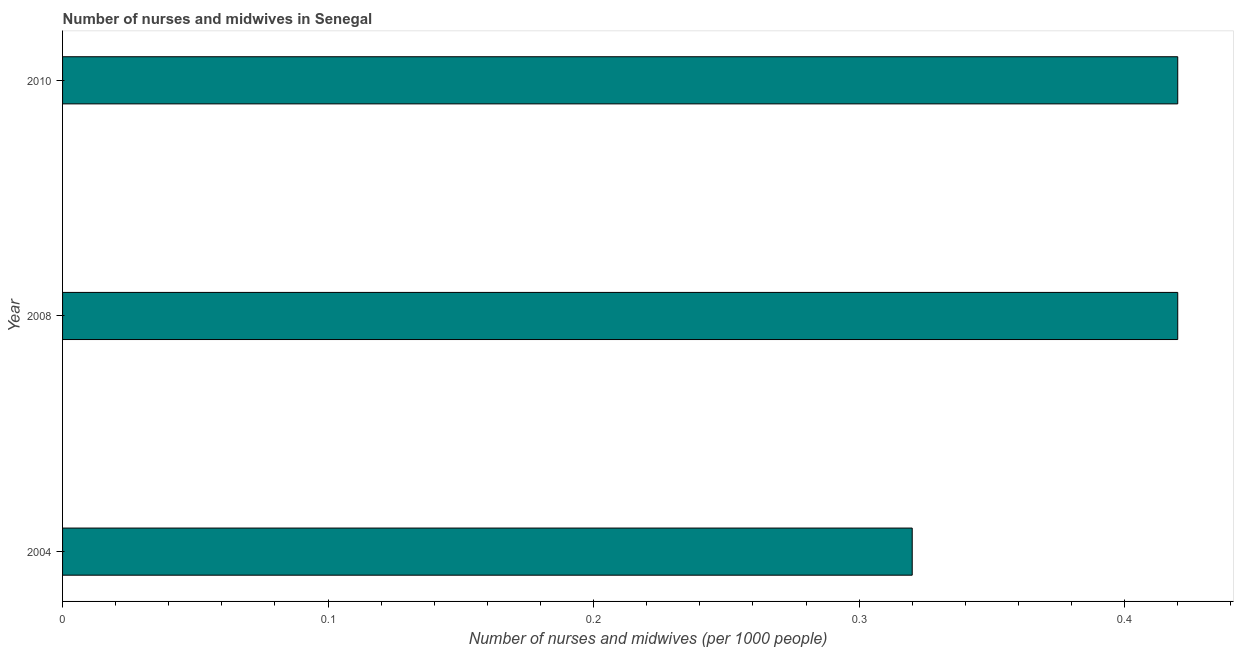What is the title of the graph?
Your answer should be very brief. Number of nurses and midwives in Senegal. What is the label or title of the X-axis?
Ensure brevity in your answer.  Number of nurses and midwives (per 1000 people). What is the label or title of the Y-axis?
Your answer should be very brief. Year. What is the number of nurses and midwives in 2010?
Offer a very short reply. 0.42. Across all years, what is the maximum number of nurses and midwives?
Ensure brevity in your answer.  0.42. Across all years, what is the minimum number of nurses and midwives?
Keep it short and to the point. 0.32. What is the sum of the number of nurses and midwives?
Give a very brief answer. 1.16. What is the average number of nurses and midwives per year?
Provide a succinct answer. 0.39. What is the median number of nurses and midwives?
Your answer should be compact. 0.42. In how many years, is the number of nurses and midwives greater than 0.04 ?
Provide a short and direct response. 3. What is the ratio of the number of nurses and midwives in 2004 to that in 2010?
Offer a terse response. 0.76. Is the number of nurses and midwives in 2004 less than that in 2008?
Offer a very short reply. Yes. Is the difference between the number of nurses and midwives in 2004 and 2008 greater than the difference between any two years?
Give a very brief answer. Yes. What is the difference between the highest and the second highest number of nurses and midwives?
Provide a succinct answer. 0. In how many years, is the number of nurses and midwives greater than the average number of nurses and midwives taken over all years?
Keep it short and to the point. 2. How many bars are there?
Give a very brief answer. 3. Are all the bars in the graph horizontal?
Keep it short and to the point. Yes. How many years are there in the graph?
Provide a short and direct response. 3. What is the Number of nurses and midwives (per 1000 people) of 2004?
Provide a succinct answer. 0.32. What is the Number of nurses and midwives (per 1000 people) of 2008?
Ensure brevity in your answer.  0.42. What is the Number of nurses and midwives (per 1000 people) in 2010?
Your response must be concise. 0.42. What is the difference between the Number of nurses and midwives (per 1000 people) in 2004 and 2008?
Your response must be concise. -0.1. What is the difference between the Number of nurses and midwives (per 1000 people) in 2008 and 2010?
Your answer should be compact. 0. What is the ratio of the Number of nurses and midwives (per 1000 people) in 2004 to that in 2008?
Offer a terse response. 0.76. What is the ratio of the Number of nurses and midwives (per 1000 people) in 2004 to that in 2010?
Your response must be concise. 0.76. 